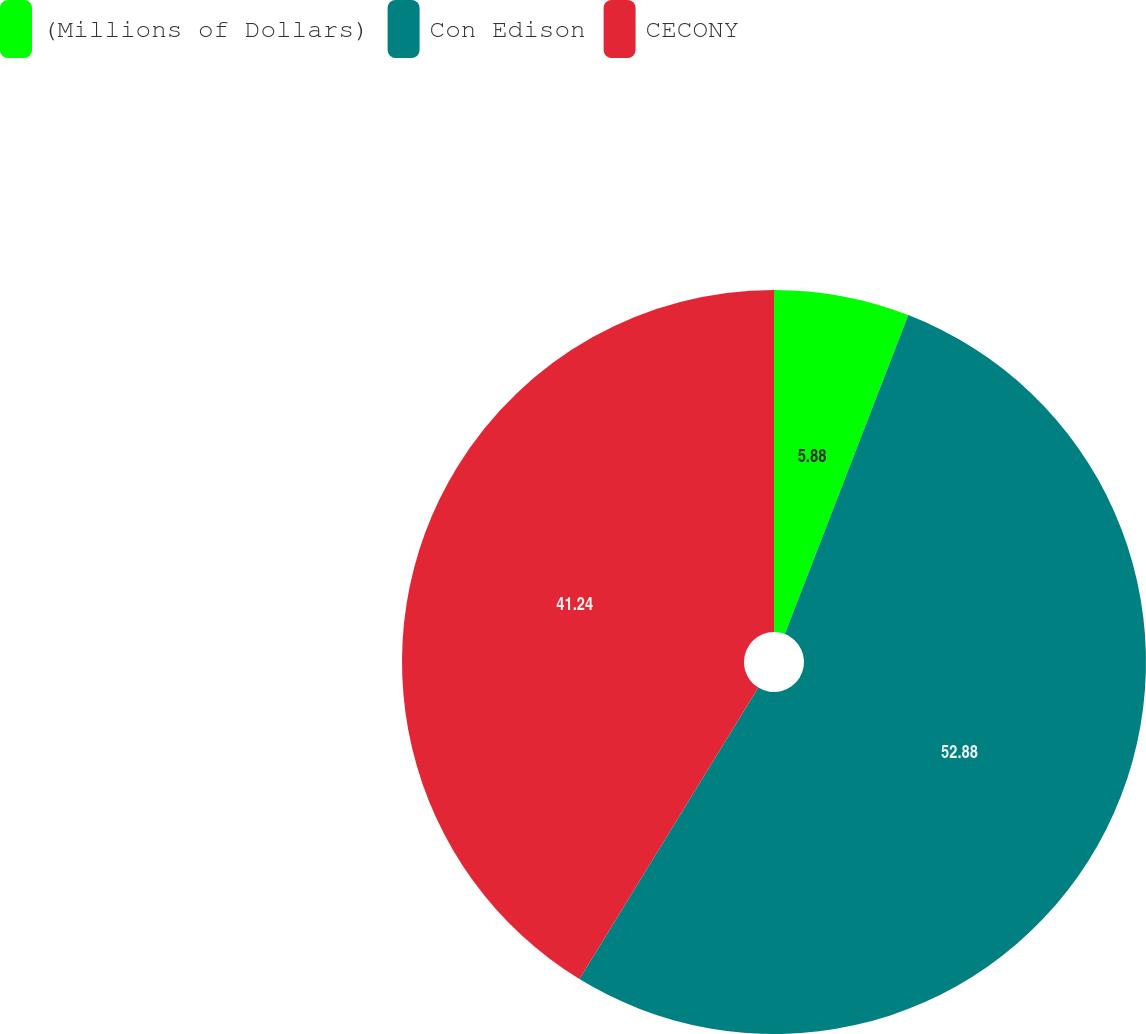Convert chart. <chart><loc_0><loc_0><loc_500><loc_500><pie_chart><fcel>(Millions of Dollars)<fcel>Con Edison<fcel>CECONY<nl><fcel>5.88%<fcel>52.88%<fcel>41.24%<nl></chart> 